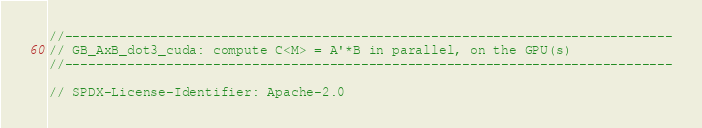<code> <loc_0><loc_0><loc_500><loc_500><_Cuda_>//------------------------------------------------------------------------------
// GB_AxB_dot3_cuda: compute C<M> = A'*B in parallel, on the GPU(s)
//------------------------------------------------------------------------------

// SPDX-License-Identifier: Apache-2.0</code> 